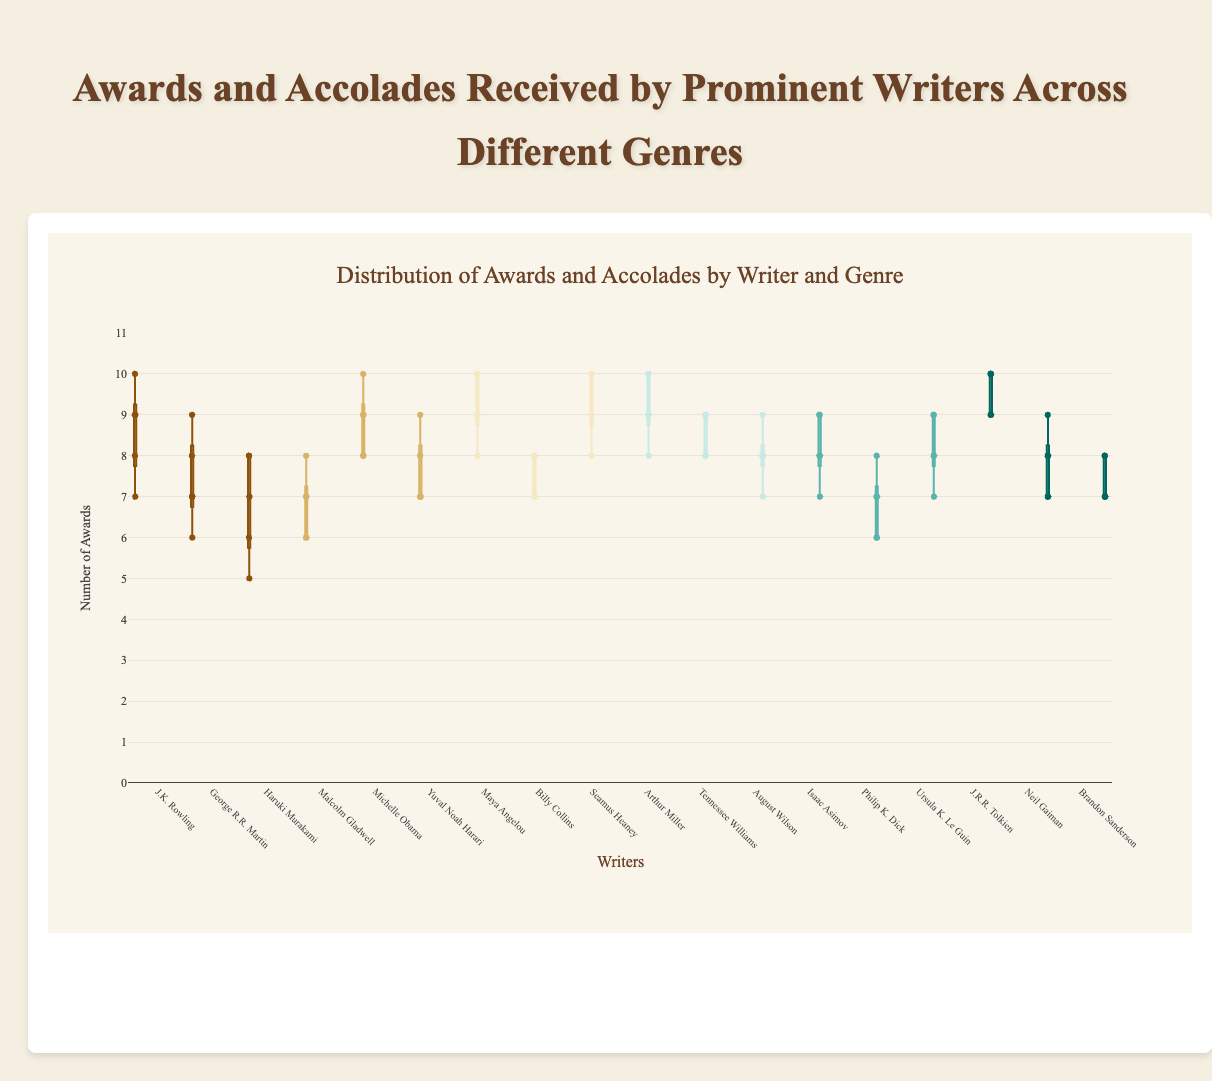What is the title of the figure? The title of the figure is displayed prominently at the top and is "Awards and Accolades Received by Prominent Writers Across Different Genres".
Answer: Awards and Accolades Received by Prominent Writers Across Different Genres Which genre has the writer with the highest median number of awards? The box representing each writer shows the median line inside the box. J.R.R. Tolkien in the Fantasy genre has the highest median, indicated by the central line in his box.
Answer: Fantasy How many data points are there in the awards distribution for George R.R. Martin? Data points are shown as individual markers on the box plot. Counting the points within George R.R. Martin's box reveals a total of 5 points.
Answer: 5 What is the interquartile range (IQR) for Seamus Heaney's awards? To find the IQR, subtract the value at the lower quartile (Q1) from the value at the upper quartile (Q3). For Seamus Heaney, Q1 is 9 and Q3 is 10. Therefore, IQR = 10 - 9 = 1.
Answer: 1 Who has the most consistent number of awards in the Drama genre? Consistency can be inferred from the smallest spread (distance between the whiskers). August Wilson shows the narrowest range in the Drama genre.
Answer: August Wilson Compare the median number of awards for Isaac Asimov and Ursula K. Le Guin. Who has more? The median is the line inside the box. Isaac Asimov's median is 8, while Ursula K. Le Guin's is also 8. Thus, both have the same median.
Answer: Same What are the maximum and minimum number of awards for Maya Angelou in Poetry? The maximum and minimum values are the ends of the whiskers. For Maya Angelou, the maximum is 10 and the minimum is 8.
Answer: Maximum: 10, Minimum: 8 Which writer in NonFiction has the highest range of awards received? The range is the difference between the max and min values (whiskers). Michelle Obama has the widest range (10 - 8 = 2), compared to Malcolm Gladwell (8 - 6 = 2) and Yuval Noah Harari (9 - 7 = 2).
Answer: Michelle Obama Compare the upper quartile (Q3) of J.K. Rowling and J.R.R. Tolkien. Who has a higher Q3, and what is the difference? Q3 is the top edge of the box. J.K. Rowling's Q3 is 9.5, while J.R.R. Tolkien's Q3 is 10. The difference is 10 - 9.5 = 0.5.
Answer: J.R.R. Tolkien, Difference: 0.5 